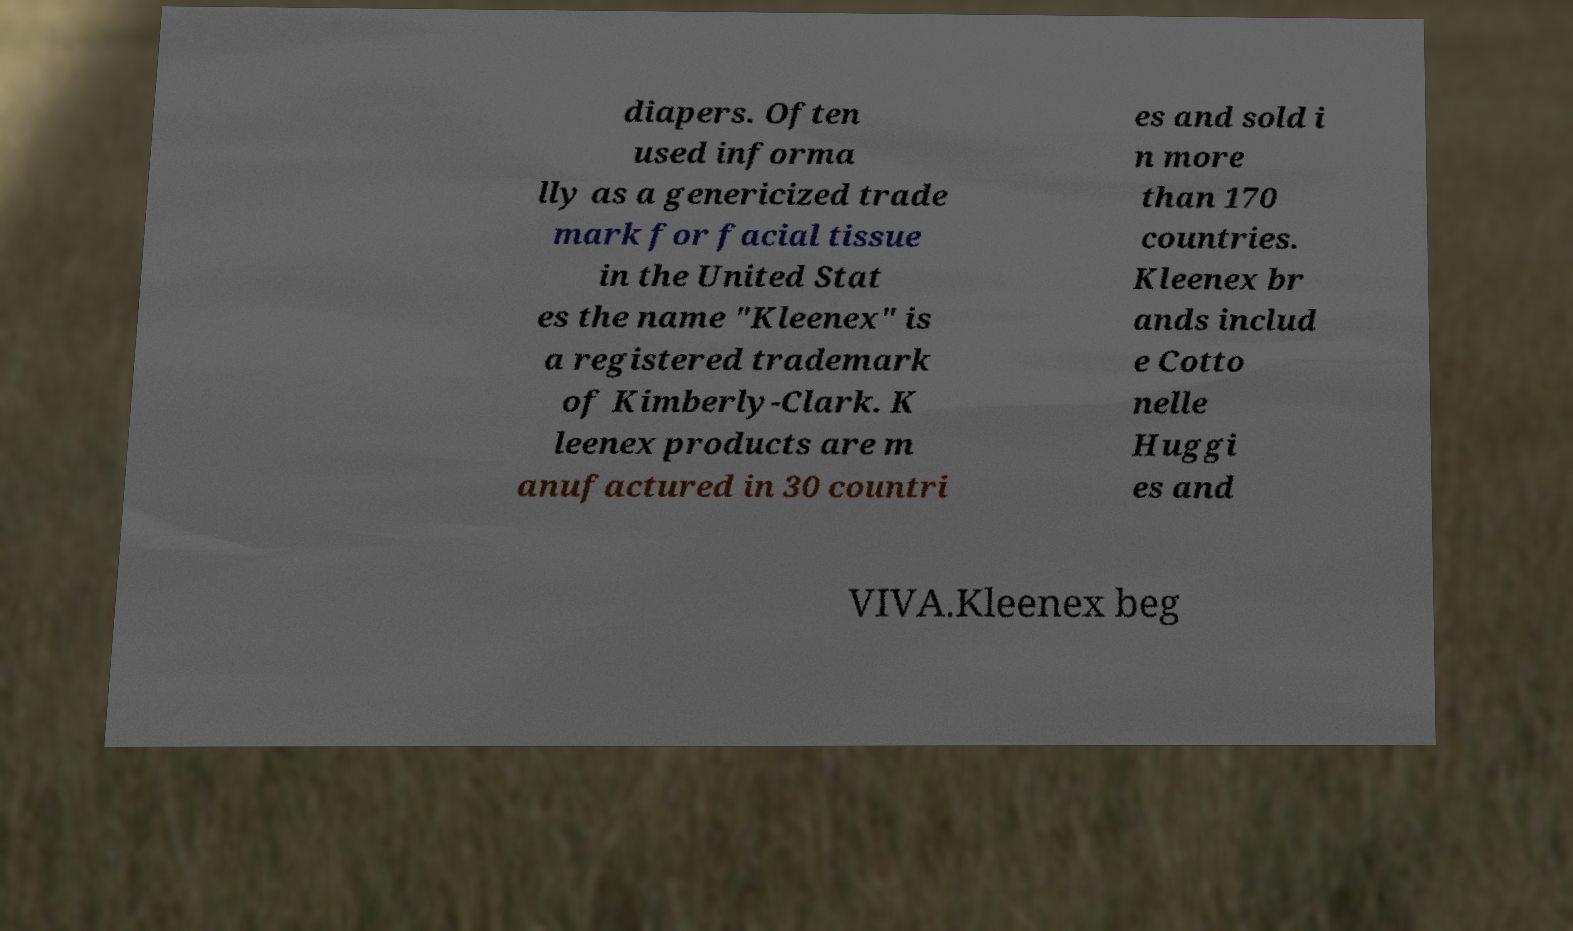For documentation purposes, I need the text within this image transcribed. Could you provide that? diapers. Often used informa lly as a genericized trade mark for facial tissue in the United Stat es the name "Kleenex" is a registered trademark of Kimberly-Clark. K leenex products are m anufactured in 30 countri es and sold i n more than 170 countries. Kleenex br ands includ e Cotto nelle Huggi es and VIVA.Kleenex beg 